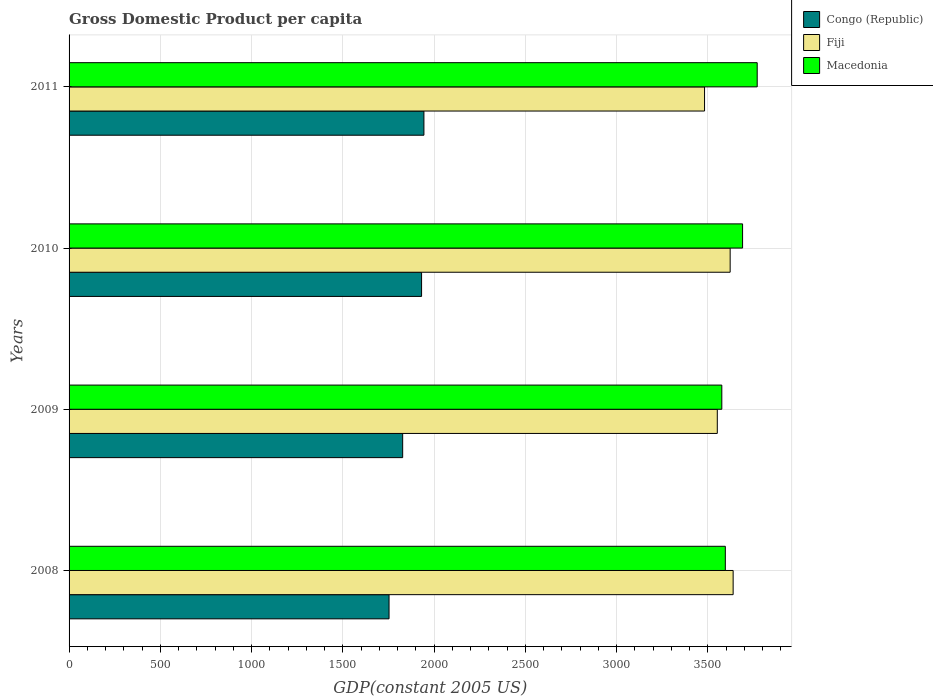How many groups of bars are there?
Your response must be concise. 4. Are the number of bars per tick equal to the number of legend labels?
Offer a very short reply. Yes. Are the number of bars on each tick of the Y-axis equal?
Provide a short and direct response. Yes. How many bars are there on the 4th tick from the top?
Give a very brief answer. 3. What is the GDP per capita in Fiji in 2009?
Your answer should be compact. 3551.33. Across all years, what is the maximum GDP per capita in Fiji?
Make the answer very short. 3638.18. Across all years, what is the minimum GDP per capita in Congo (Republic)?
Keep it short and to the point. 1753.02. What is the total GDP per capita in Congo (Republic) in the graph?
Ensure brevity in your answer.  7456.03. What is the difference between the GDP per capita in Congo (Republic) in 2010 and that in 2011?
Offer a terse response. -12.82. What is the difference between the GDP per capita in Congo (Republic) in 2010 and the GDP per capita in Fiji in 2011?
Your answer should be very brief. -1550.23. What is the average GDP per capita in Macedonia per year?
Ensure brevity in your answer.  3657.83. In the year 2009, what is the difference between the GDP per capita in Fiji and GDP per capita in Congo (Republic)?
Provide a short and direct response. 1723.66. In how many years, is the GDP per capita in Macedonia greater than 2400 US$?
Give a very brief answer. 4. What is the ratio of the GDP per capita in Congo (Republic) in 2008 to that in 2010?
Make the answer very short. 0.91. Is the GDP per capita in Fiji in 2008 less than that in 2009?
Provide a succinct answer. No. What is the difference between the highest and the second highest GDP per capita in Fiji?
Your response must be concise. 16.35. What is the difference between the highest and the lowest GDP per capita in Macedonia?
Ensure brevity in your answer.  193.84. In how many years, is the GDP per capita in Fiji greater than the average GDP per capita in Fiji taken over all years?
Provide a short and direct response. 2. What does the 1st bar from the top in 2011 represents?
Give a very brief answer. Macedonia. What does the 3rd bar from the bottom in 2011 represents?
Ensure brevity in your answer.  Macedonia. Is it the case that in every year, the sum of the GDP per capita in Macedonia and GDP per capita in Congo (Republic) is greater than the GDP per capita in Fiji?
Give a very brief answer. Yes. How many years are there in the graph?
Your response must be concise. 4. Does the graph contain any zero values?
Offer a terse response. No. How are the legend labels stacked?
Keep it short and to the point. Vertical. What is the title of the graph?
Offer a terse response. Gross Domestic Product per capita. Does "Channel Islands" appear as one of the legend labels in the graph?
Your response must be concise. No. What is the label or title of the X-axis?
Provide a succinct answer. GDP(constant 2005 US). What is the label or title of the Y-axis?
Your answer should be very brief. Years. What is the GDP(constant 2005 US) in Congo (Republic) in 2008?
Offer a terse response. 1753.02. What is the GDP(constant 2005 US) of Fiji in 2008?
Ensure brevity in your answer.  3638.18. What is the GDP(constant 2005 US) of Macedonia in 2008?
Ensure brevity in your answer.  3595.36. What is the GDP(constant 2005 US) of Congo (Republic) in 2009?
Give a very brief answer. 1827.67. What is the GDP(constant 2005 US) of Fiji in 2009?
Your answer should be compact. 3551.33. What is the GDP(constant 2005 US) in Macedonia in 2009?
Give a very brief answer. 3576.11. What is the GDP(constant 2005 US) in Congo (Republic) in 2010?
Keep it short and to the point. 1931.26. What is the GDP(constant 2005 US) of Fiji in 2010?
Offer a terse response. 3621.83. What is the GDP(constant 2005 US) of Macedonia in 2010?
Your answer should be compact. 3689.91. What is the GDP(constant 2005 US) of Congo (Republic) in 2011?
Provide a short and direct response. 1944.08. What is the GDP(constant 2005 US) in Fiji in 2011?
Your answer should be very brief. 3481.49. What is the GDP(constant 2005 US) of Macedonia in 2011?
Make the answer very short. 3769.95. Across all years, what is the maximum GDP(constant 2005 US) of Congo (Republic)?
Provide a succinct answer. 1944.08. Across all years, what is the maximum GDP(constant 2005 US) of Fiji?
Provide a succinct answer. 3638.18. Across all years, what is the maximum GDP(constant 2005 US) of Macedonia?
Make the answer very short. 3769.95. Across all years, what is the minimum GDP(constant 2005 US) of Congo (Republic)?
Offer a terse response. 1753.02. Across all years, what is the minimum GDP(constant 2005 US) in Fiji?
Offer a very short reply. 3481.49. Across all years, what is the minimum GDP(constant 2005 US) in Macedonia?
Offer a terse response. 3576.11. What is the total GDP(constant 2005 US) in Congo (Republic) in the graph?
Keep it short and to the point. 7456.03. What is the total GDP(constant 2005 US) of Fiji in the graph?
Ensure brevity in your answer.  1.43e+04. What is the total GDP(constant 2005 US) in Macedonia in the graph?
Keep it short and to the point. 1.46e+04. What is the difference between the GDP(constant 2005 US) in Congo (Republic) in 2008 and that in 2009?
Your answer should be very brief. -74.65. What is the difference between the GDP(constant 2005 US) in Fiji in 2008 and that in 2009?
Your answer should be compact. 86.85. What is the difference between the GDP(constant 2005 US) of Macedonia in 2008 and that in 2009?
Provide a short and direct response. 19.25. What is the difference between the GDP(constant 2005 US) of Congo (Republic) in 2008 and that in 2010?
Offer a very short reply. -178.25. What is the difference between the GDP(constant 2005 US) in Fiji in 2008 and that in 2010?
Keep it short and to the point. 16.35. What is the difference between the GDP(constant 2005 US) of Macedonia in 2008 and that in 2010?
Provide a succinct answer. -94.55. What is the difference between the GDP(constant 2005 US) of Congo (Republic) in 2008 and that in 2011?
Provide a succinct answer. -191.07. What is the difference between the GDP(constant 2005 US) of Fiji in 2008 and that in 2011?
Ensure brevity in your answer.  156.68. What is the difference between the GDP(constant 2005 US) in Macedonia in 2008 and that in 2011?
Keep it short and to the point. -174.59. What is the difference between the GDP(constant 2005 US) in Congo (Republic) in 2009 and that in 2010?
Make the answer very short. -103.59. What is the difference between the GDP(constant 2005 US) of Fiji in 2009 and that in 2010?
Your answer should be very brief. -70.5. What is the difference between the GDP(constant 2005 US) in Macedonia in 2009 and that in 2010?
Ensure brevity in your answer.  -113.8. What is the difference between the GDP(constant 2005 US) of Congo (Republic) in 2009 and that in 2011?
Your answer should be very brief. -116.41. What is the difference between the GDP(constant 2005 US) of Fiji in 2009 and that in 2011?
Keep it short and to the point. 69.83. What is the difference between the GDP(constant 2005 US) of Macedonia in 2009 and that in 2011?
Offer a very short reply. -193.84. What is the difference between the GDP(constant 2005 US) in Congo (Republic) in 2010 and that in 2011?
Offer a very short reply. -12.82. What is the difference between the GDP(constant 2005 US) of Fiji in 2010 and that in 2011?
Offer a very short reply. 140.33. What is the difference between the GDP(constant 2005 US) of Macedonia in 2010 and that in 2011?
Offer a very short reply. -80.04. What is the difference between the GDP(constant 2005 US) of Congo (Republic) in 2008 and the GDP(constant 2005 US) of Fiji in 2009?
Ensure brevity in your answer.  -1798.31. What is the difference between the GDP(constant 2005 US) of Congo (Republic) in 2008 and the GDP(constant 2005 US) of Macedonia in 2009?
Your answer should be very brief. -1823.09. What is the difference between the GDP(constant 2005 US) of Fiji in 2008 and the GDP(constant 2005 US) of Macedonia in 2009?
Offer a very short reply. 62.07. What is the difference between the GDP(constant 2005 US) of Congo (Republic) in 2008 and the GDP(constant 2005 US) of Fiji in 2010?
Give a very brief answer. -1868.81. What is the difference between the GDP(constant 2005 US) of Congo (Republic) in 2008 and the GDP(constant 2005 US) of Macedonia in 2010?
Your response must be concise. -1936.89. What is the difference between the GDP(constant 2005 US) in Fiji in 2008 and the GDP(constant 2005 US) in Macedonia in 2010?
Ensure brevity in your answer.  -51.73. What is the difference between the GDP(constant 2005 US) in Congo (Republic) in 2008 and the GDP(constant 2005 US) in Fiji in 2011?
Your response must be concise. -1728.48. What is the difference between the GDP(constant 2005 US) in Congo (Republic) in 2008 and the GDP(constant 2005 US) in Macedonia in 2011?
Your answer should be very brief. -2016.93. What is the difference between the GDP(constant 2005 US) in Fiji in 2008 and the GDP(constant 2005 US) in Macedonia in 2011?
Ensure brevity in your answer.  -131.77. What is the difference between the GDP(constant 2005 US) in Congo (Republic) in 2009 and the GDP(constant 2005 US) in Fiji in 2010?
Offer a terse response. -1794.16. What is the difference between the GDP(constant 2005 US) in Congo (Republic) in 2009 and the GDP(constant 2005 US) in Macedonia in 2010?
Provide a succinct answer. -1862.24. What is the difference between the GDP(constant 2005 US) of Fiji in 2009 and the GDP(constant 2005 US) of Macedonia in 2010?
Make the answer very short. -138.58. What is the difference between the GDP(constant 2005 US) of Congo (Republic) in 2009 and the GDP(constant 2005 US) of Fiji in 2011?
Your answer should be compact. -1653.82. What is the difference between the GDP(constant 2005 US) of Congo (Republic) in 2009 and the GDP(constant 2005 US) of Macedonia in 2011?
Provide a succinct answer. -1942.28. What is the difference between the GDP(constant 2005 US) in Fiji in 2009 and the GDP(constant 2005 US) in Macedonia in 2011?
Ensure brevity in your answer.  -218.62. What is the difference between the GDP(constant 2005 US) in Congo (Republic) in 2010 and the GDP(constant 2005 US) in Fiji in 2011?
Your answer should be very brief. -1550.23. What is the difference between the GDP(constant 2005 US) in Congo (Republic) in 2010 and the GDP(constant 2005 US) in Macedonia in 2011?
Your response must be concise. -1838.69. What is the difference between the GDP(constant 2005 US) in Fiji in 2010 and the GDP(constant 2005 US) in Macedonia in 2011?
Your answer should be very brief. -148.12. What is the average GDP(constant 2005 US) of Congo (Republic) per year?
Offer a terse response. 1864.01. What is the average GDP(constant 2005 US) of Fiji per year?
Provide a succinct answer. 3573.21. What is the average GDP(constant 2005 US) of Macedonia per year?
Your response must be concise. 3657.83. In the year 2008, what is the difference between the GDP(constant 2005 US) of Congo (Republic) and GDP(constant 2005 US) of Fiji?
Offer a terse response. -1885.16. In the year 2008, what is the difference between the GDP(constant 2005 US) of Congo (Republic) and GDP(constant 2005 US) of Macedonia?
Provide a succinct answer. -1842.34. In the year 2008, what is the difference between the GDP(constant 2005 US) of Fiji and GDP(constant 2005 US) of Macedonia?
Offer a very short reply. 42.82. In the year 2009, what is the difference between the GDP(constant 2005 US) in Congo (Republic) and GDP(constant 2005 US) in Fiji?
Offer a terse response. -1723.66. In the year 2009, what is the difference between the GDP(constant 2005 US) in Congo (Republic) and GDP(constant 2005 US) in Macedonia?
Make the answer very short. -1748.44. In the year 2009, what is the difference between the GDP(constant 2005 US) of Fiji and GDP(constant 2005 US) of Macedonia?
Offer a terse response. -24.78. In the year 2010, what is the difference between the GDP(constant 2005 US) of Congo (Republic) and GDP(constant 2005 US) of Fiji?
Keep it short and to the point. -1690.56. In the year 2010, what is the difference between the GDP(constant 2005 US) of Congo (Republic) and GDP(constant 2005 US) of Macedonia?
Keep it short and to the point. -1758.64. In the year 2010, what is the difference between the GDP(constant 2005 US) of Fiji and GDP(constant 2005 US) of Macedonia?
Provide a short and direct response. -68.08. In the year 2011, what is the difference between the GDP(constant 2005 US) in Congo (Republic) and GDP(constant 2005 US) in Fiji?
Make the answer very short. -1537.41. In the year 2011, what is the difference between the GDP(constant 2005 US) in Congo (Republic) and GDP(constant 2005 US) in Macedonia?
Provide a short and direct response. -1825.87. In the year 2011, what is the difference between the GDP(constant 2005 US) of Fiji and GDP(constant 2005 US) of Macedonia?
Keep it short and to the point. -288.46. What is the ratio of the GDP(constant 2005 US) of Congo (Republic) in 2008 to that in 2009?
Provide a short and direct response. 0.96. What is the ratio of the GDP(constant 2005 US) in Fiji in 2008 to that in 2009?
Keep it short and to the point. 1.02. What is the ratio of the GDP(constant 2005 US) of Macedonia in 2008 to that in 2009?
Make the answer very short. 1.01. What is the ratio of the GDP(constant 2005 US) of Congo (Republic) in 2008 to that in 2010?
Your response must be concise. 0.91. What is the ratio of the GDP(constant 2005 US) of Fiji in 2008 to that in 2010?
Ensure brevity in your answer.  1. What is the ratio of the GDP(constant 2005 US) of Macedonia in 2008 to that in 2010?
Your response must be concise. 0.97. What is the ratio of the GDP(constant 2005 US) of Congo (Republic) in 2008 to that in 2011?
Your response must be concise. 0.9. What is the ratio of the GDP(constant 2005 US) of Fiji in 2008 to that in 2011?
Give a very brief answer. 1.04. What is the ratio of the GDP(constant 2005 US) of Macedonia in 2008 to that in 2011?
Offer a very short reply. 0.95. What is the ratio of the GDP(constant 2005 US) in Congo (Republic) in 2009 to that in 2010?
Offer a terse response. 0.95. What is the ratio of the GDP(constant 2005 US) in Fiji in 2009 to that in 2010?
Make the answer very short. 0.98. What is the ratio of the GDP(constant 2005 US) in Macedonia in 2009 to that in 2010?
Your answer should be compact. 0.97. What is the ratio of the GDP(constant 2005 US) in Congo (Republic) in 2009 to that in 2011?
Offer a terse response. 0.94. What is the ratio of the GDP(constant 2005 US) in Fiji in 2009 to that in 2011?
Provide a short and direct response. 1.02. What is the ratio of the GDP(constant 2005 US) of Macedonia in 2009 to that in 2011?
Your answer should be compact. 0.95. What is the ratio of the GDP(constant 2005 US) in Fiji in 2010 to that in 2011?
Offer a very short reply. 1.04. What is the ratio of the GDP(constant 2005 US) in Macedonia in 2010 to that in 2011?
Your answer should be compact. 0.98. What is the difference between the highest and the second highest GDP(constant 2005 US) in Congo (Republic)?
Your answer should be very brief. 12.82. What is the difference between the highest and the second highest GDP(constant 2005 US) of Fiji?
Your answer should be very brief. 16.35. What is the difference between the highest and the second highest GDP(constant 2005 US) in Macedonia?
Make the answer very short. 80.04. What is the difference between the highest and the lowest GDP(constant 2005 US) in Congo (Republic)?
Give a very brief answer. 191.07. What is the difference between the highest and the lowest GDP(constant 2005 US) in Fiji?
Your answer should be compact. 156.68. What is the difference between the highest and the lowest GDP(constant 2005 US) in Macedonia?
Keep it short and to the point. 193.84. 